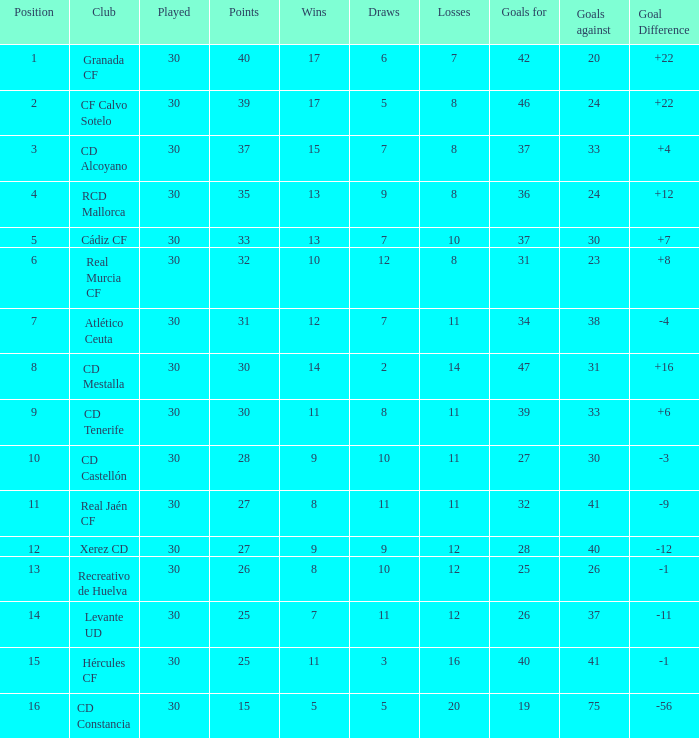What is the number of draws with 30 points and under 33 goals against? 1.0. 